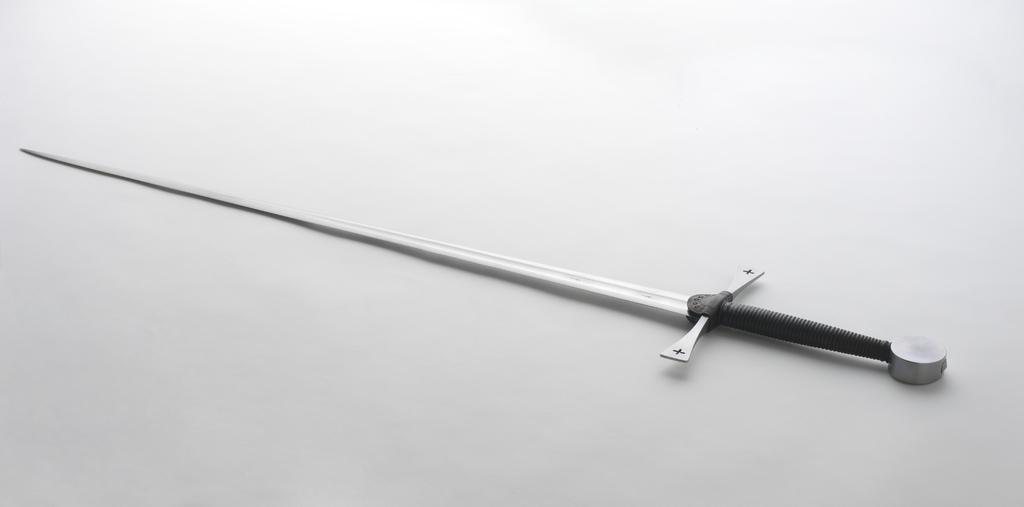In one or two sentences, can you explain what this image depicts? In this image we can see black and white picture of a sword placed on the surface. 